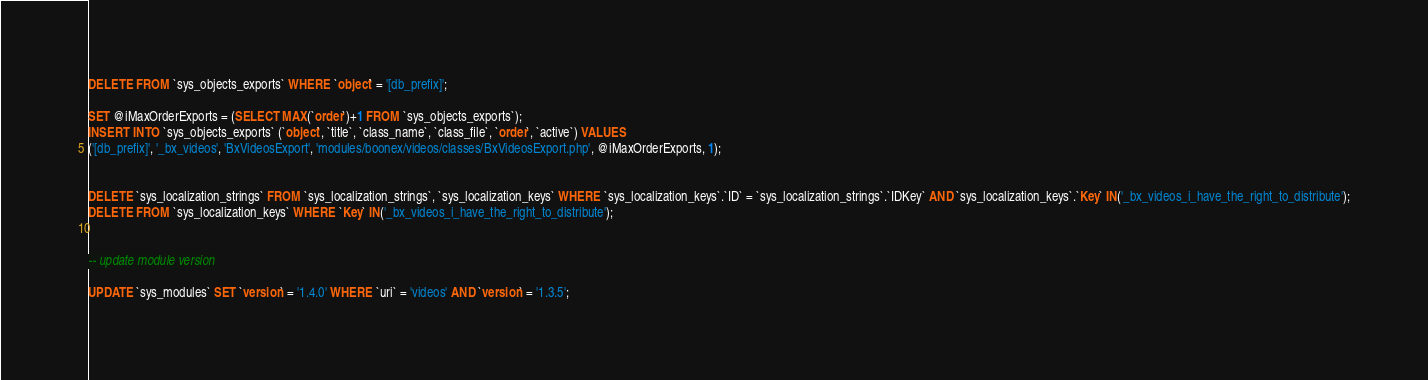Convert code to text. <code><loc_0><loc_0><loc_500><loc_500><_SQL_>

DELETE FROM `sys_objects_exports` WHERE `object` = '[db_prefix]';

SET @iMaxOrderExports = (SELECT MAX(`order`)+1 FROM `sys_objects_exports`);
INSERT INTO `sys_objects_exports` (`object`, `title`, `class_name`, `class_file`, `order`, `active`) VALUES
('[db_prefix]', '_bx_videos', 'BxVideosExport', 'modules/boonex/videos/classes/BxVideosExport.php', @iMaxOrderExports, 1);


DELETE `sys_localization_strings` FROM `sys_localization_strings`, `sys_localization_keys` WHERE `sys_localization_keys`.`ID` = `sys_localization_strings`.`IDKey` AND `sys_localization_keys`.`Key` IN('_bx_videos_i_have_the_right_to_distribute');
DELETE FROM `sys_localization_keys` WHERE `Key` IN('_bx_videos_i_have_the_right_to_distribute');


-- update module version

UPDATE `sys_modules` SET `version` = '1.4.0' WHERE `uri` = 'videos' AND `version` = '1.3.5';

</code> 